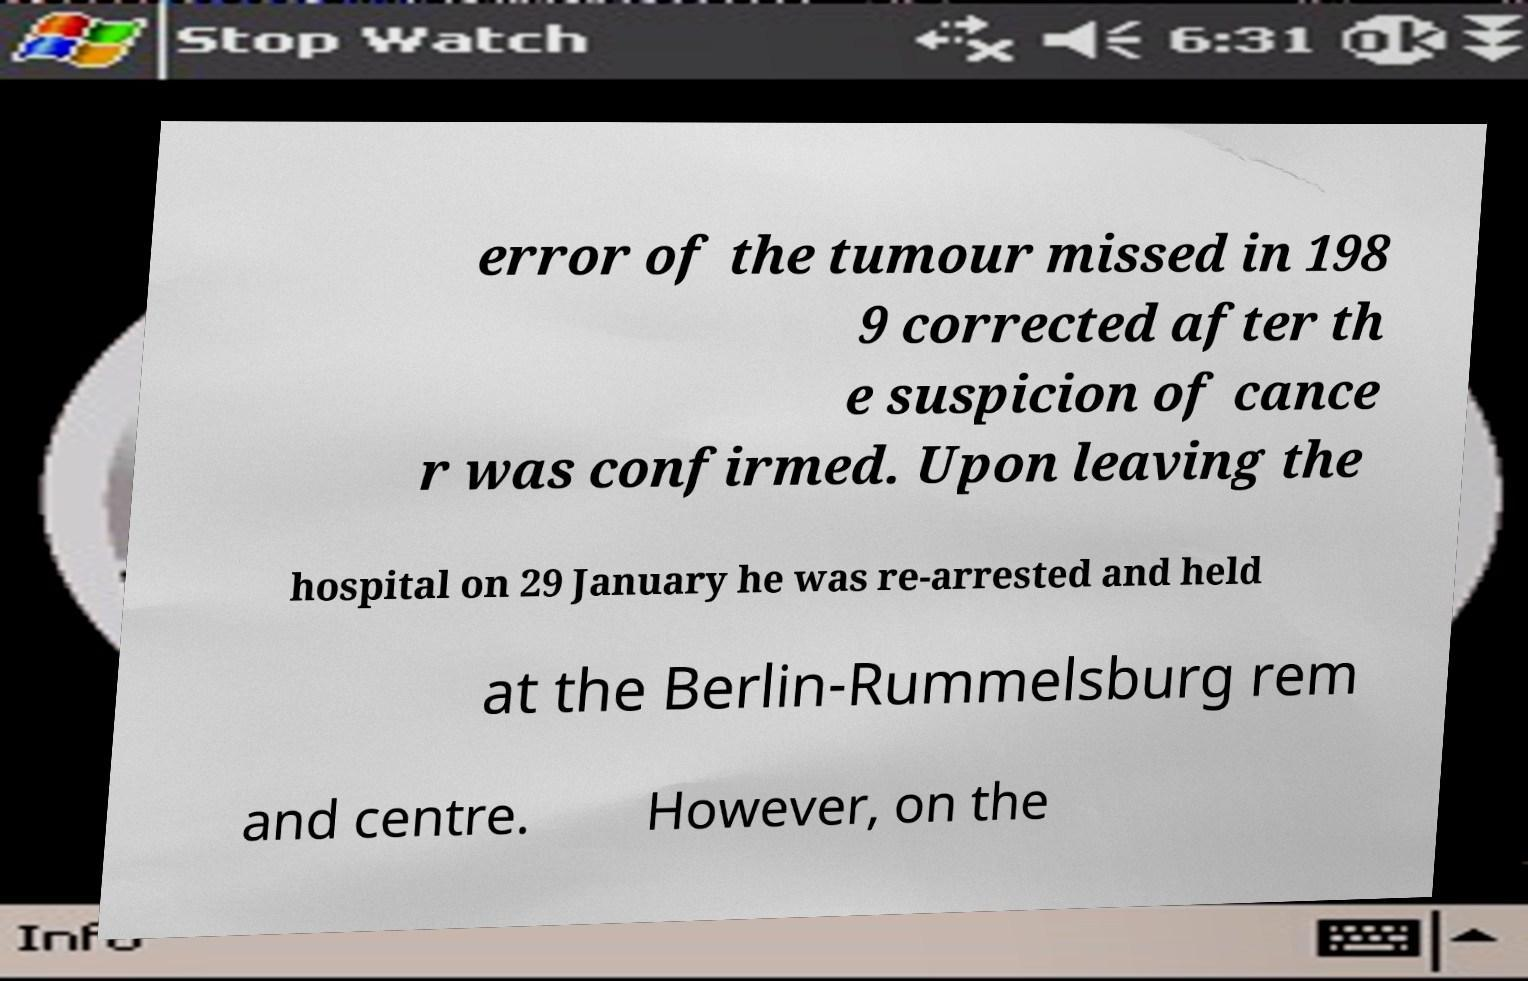There's text embedded in this image that I need extracted. Can you transcribe it verbatim? error of the tumour missed in 198 9 corrected after th e suspicion of cance r was confirmed. Upon leaving the hospital on 29 January he was re-arrested and held at the Berlin-Rummelsburg rem and centre. However, on the 